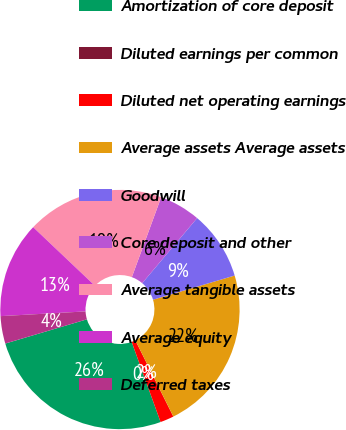Convert chart. <chart><loc_0><loc_0><loc_500><loc_500><pie_chart><fcel>Amortization of core deposit<fcel>Diluted earnings per common<fcel>Diluted net operating earnings<fcel>Average assets Average assets<fcel>Goodwill<fcel>Core deposit and other<fcel>Average tangible assets<fcel>Average equity<fcel>Deferred taxes<nl><fcel>25.92%<fcel>0.0%<fcel>1.85%<fcel>22.22%<fcel>9.26%<fcel>5.56%<fcel>18.52%<fcel>12.96%<fcel>3.71%<nl></chart> 